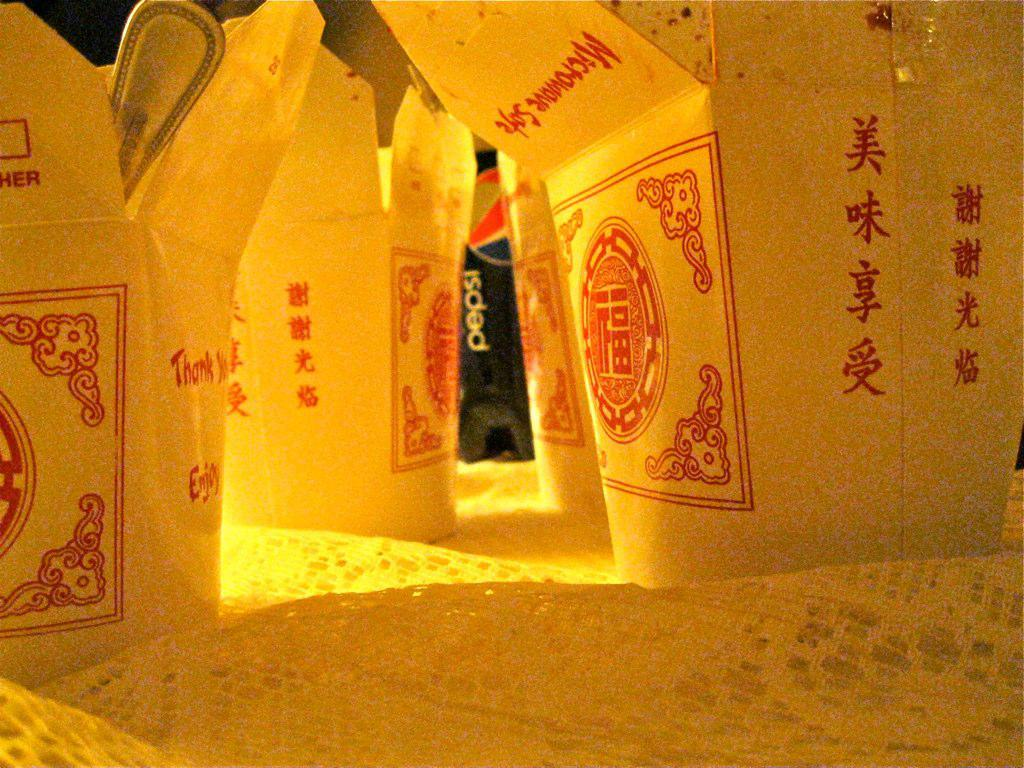<image>
Write a terse but informative summary of the picture. three boxes of chinese takeout with "thank you" being just visible on one. 